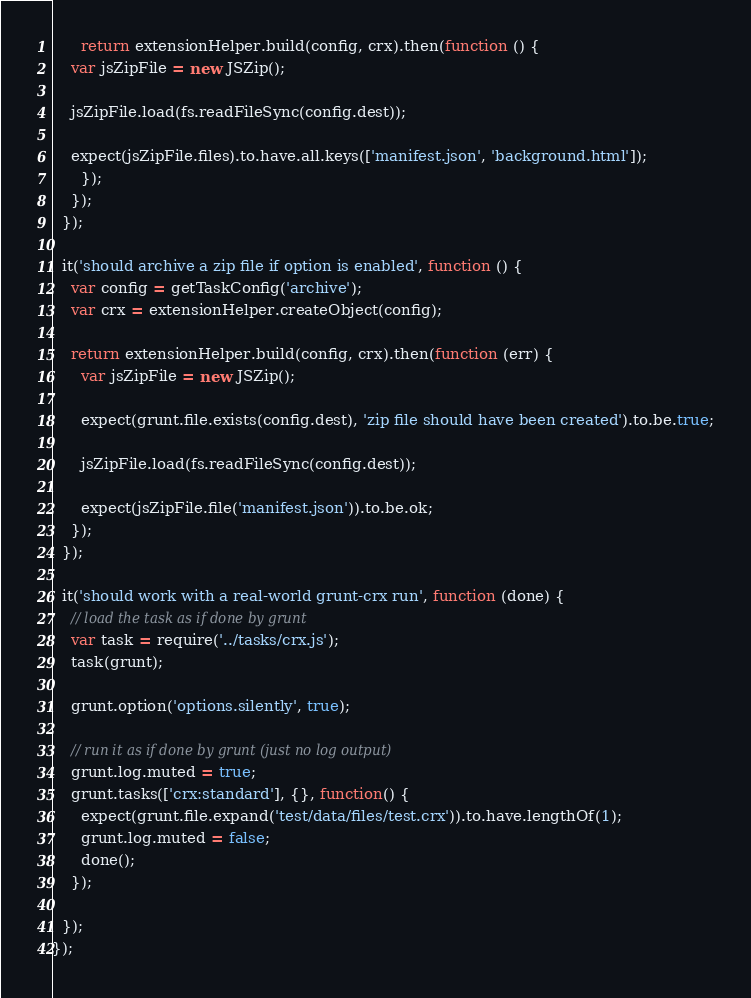Convert code to text. <code><loc_0><loc_0><loc_500><loc_500><_JavaScript_>      return extensionHelper.build(config, crx).then(function () {
	var jsZipFile = new JSZip();

	jsZipFile.load(fs.readFileSync(config.dest));

	expect(jsZipFile.files).to.have.all.keys(['manifest.json', 'background.html']);
      });
    });
  });

  it('should archive a zip file if option is enabled', function () {
    var config = getTaskConfig('archive');
    var crx = extensionHelper.createObject(config);

    return extensionHelper.build(config, crx).then(function (err) {
      var jsZipFile = new JSZip();

      expect(grunt.file.exists(config.dest), 'zip file should have been created').to.be.true;

      jsZipFile.load(fs.readFileSync(config.dest));

      expect(jsZipFile.file('manifest.json')).to.be.ok;
    });
  });

  it('should work with a real-world grunt-crx run', function (done) {
    // load the task as if done by grunt
    var task = require('../tasks/crx.js');
    task(grunt);

    grunt.option('options.silently', true);

    // run it as if done by grunt (just no log output)
    grunt.log.muted = true;
    grunt.tasks(['crx:standard'], {}, function() {
      expect(grunt.file.expand('test/data/files/test.crx')).to.have.lengthOf(1);
      grunt.log.muted = false;
      done();
    });

  });
});
</code> 